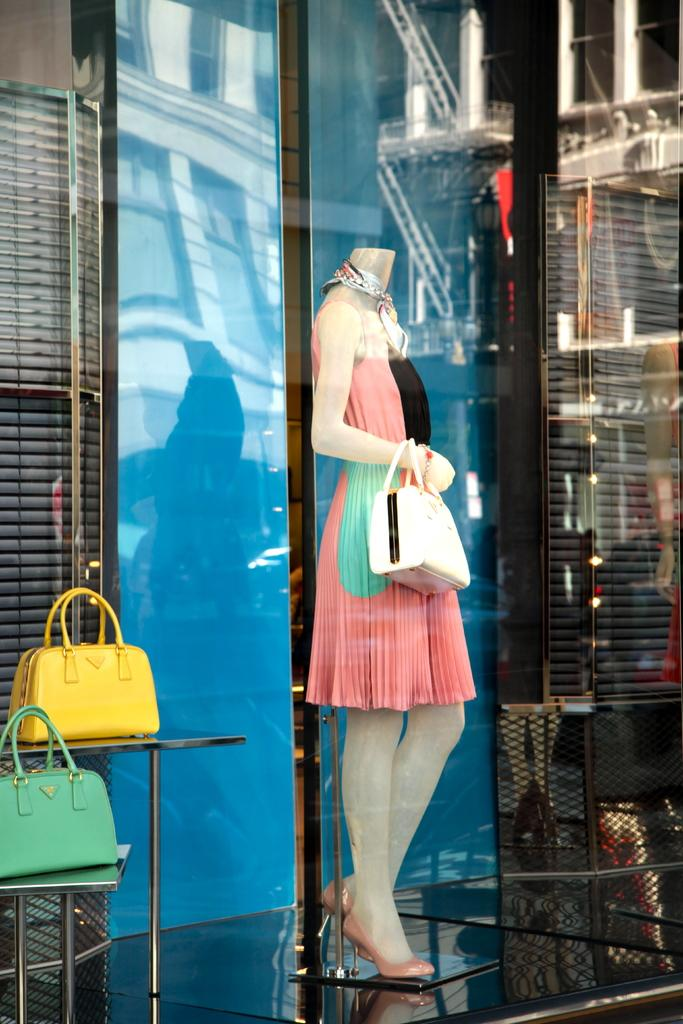What is the main subject in the image? There is a mannequin in the image. What is the mannequin holding? The mannequin is holding a bag. Can you describe the bags in the image? There are green and yellow color bags in the image. Where are the bags placed? The bags are placed on a rack for showcase. What type of grape can be seen in the image? There are no grapes present in the image. What rhythm is the mannequin following while holding the bag? The mannequin is not following any rhythm, as it is a static object in the image. 